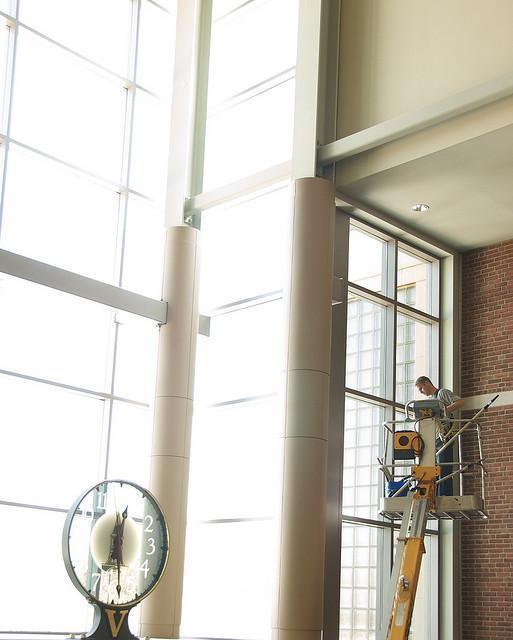How many giraffes are there?
Give a very brief answer. 0. 